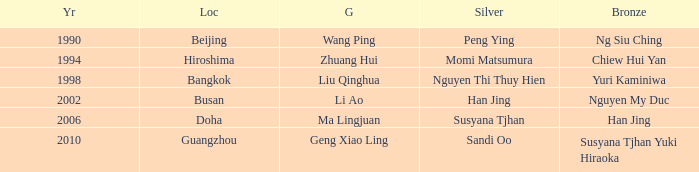What Silver has the Location of Guangzhou? Sandi Oo. 